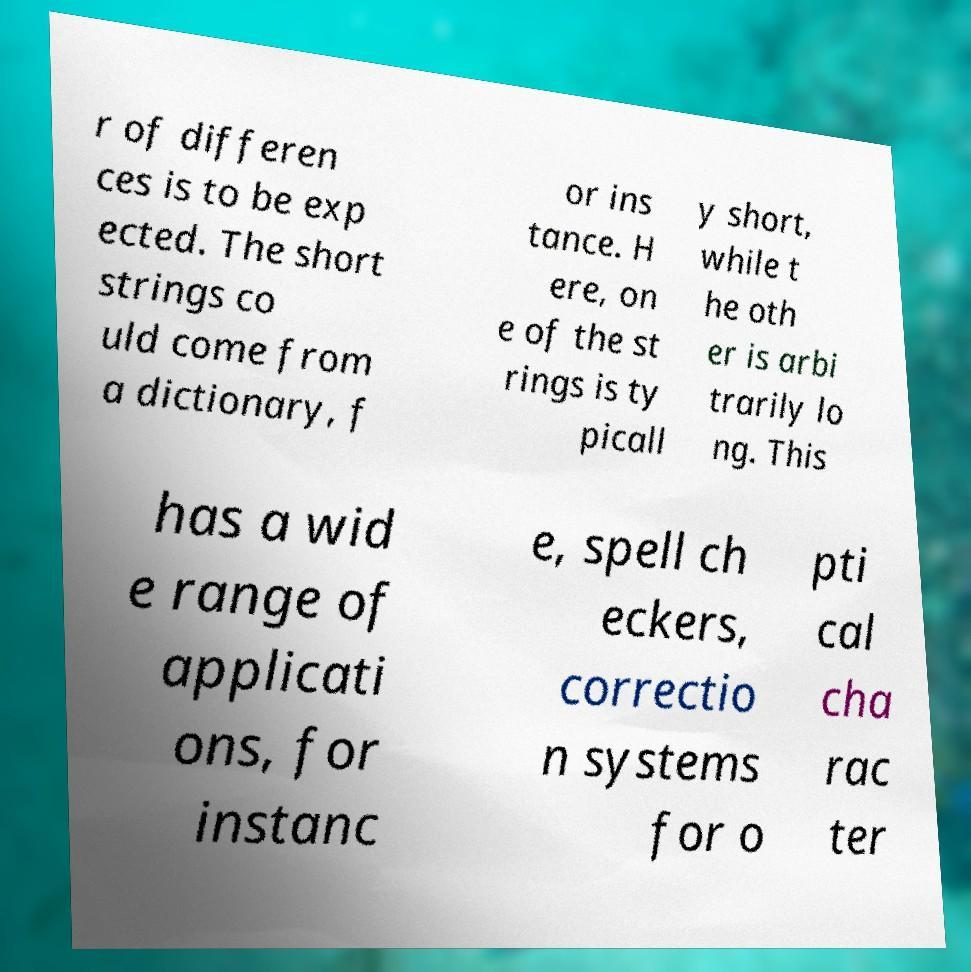Can you accurately transcribe the text from the provided image for me? r of differen ces is to be exp ected. The short strings co uld come from a dictionary, f or ins tance. H ere, on e of the st rings is ty picall y short, while t he oth er is arbi trarily lo ng. This has a wid e range of applicati ons, for instanc e, spell ch eckers, correctio n systems for o pti cal cha rac ter 